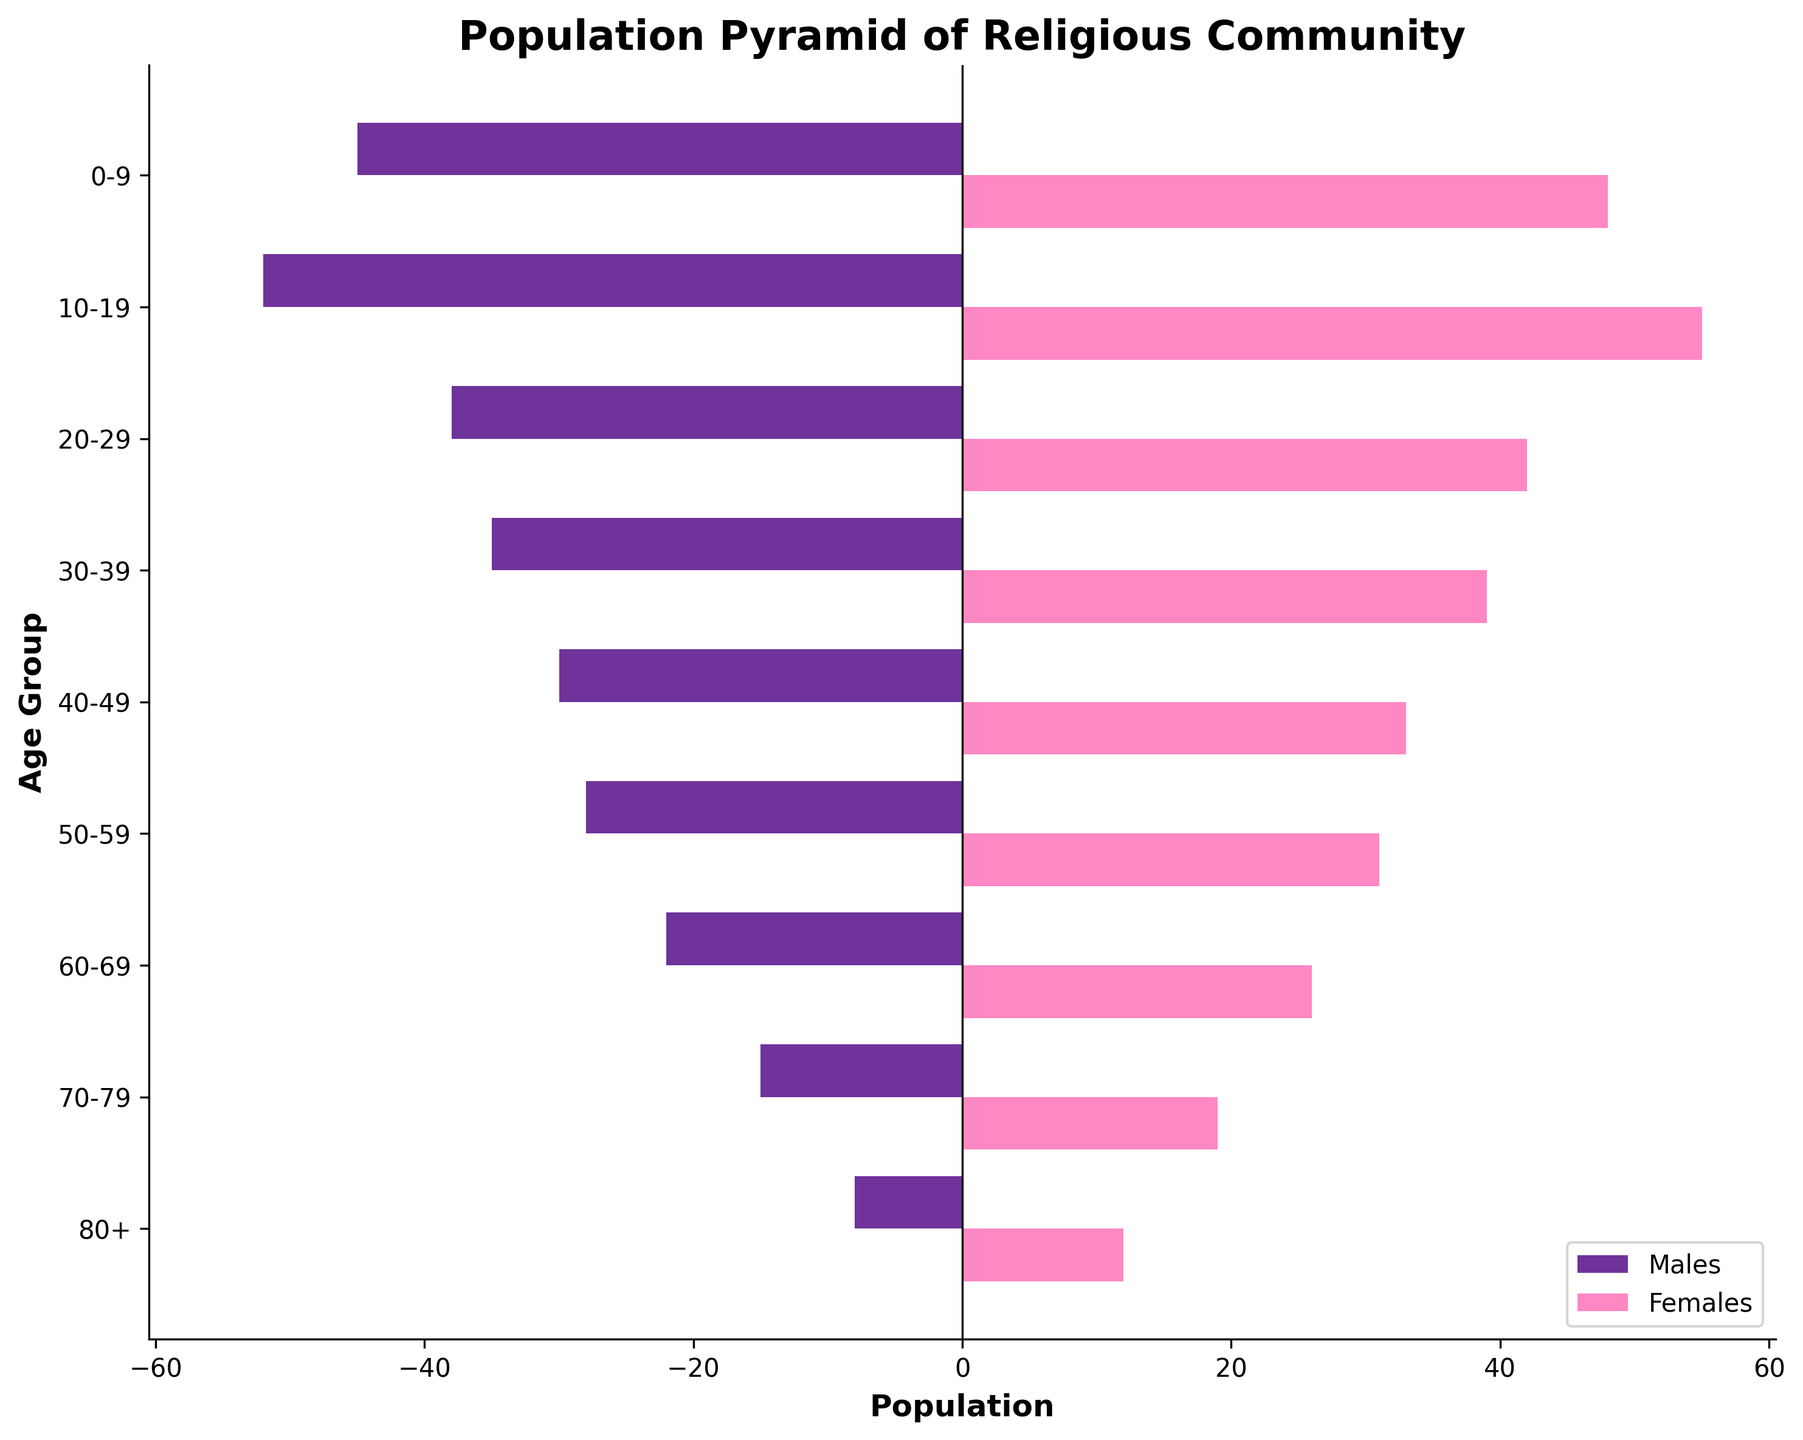How many females are in the 60-69 age group? Look at the bar representing the 60-69 age group for females and read the value shown next to the bar.
Answer: 26 Which age group has the highest number of males? Compare the lengths of the bars on the male side and identify the one that is longest. The longest bar represents the highest number of males.
Answer: 10-19 What is the total population of the community within the 20-29 age group? Add the number of males and females in the 20-29 age group: 38 (males) + 42 (females).
Answer: 80 Are there more males or females in the youngest age group (0-9)? Compare the values of males and females in the 0-9 age group.
Answer: Females How does the population of males and females compare in the 30-39 age group? Look at the bars for males and females in the 30-39 age group and compare their lengths or values.
Answer: There are more females What is the general trend in the population size as age increases? Observe the lengths of the bars from the youngest to the oldest age groups to identify the trend.
Answer: The population size decreases as age increases What is the total number of people in the 50+ age groups in the community? Add the numbers of males and females from all age groups 50 and above: 28 + 31 (50-59) + 22 + 26 (60-69) + 15 + 19 (70-79) + 8 + 12 (80+).
Answer: 161 Which age group has the least number of people in the community? Identify the age group with the shortest bars (combining both males and females).
Answer: 80+ Is there any age group where the number of males equals the number of females? Check if there are any age groups where the lengths of the bars for males and females are the same.
Answer: No 